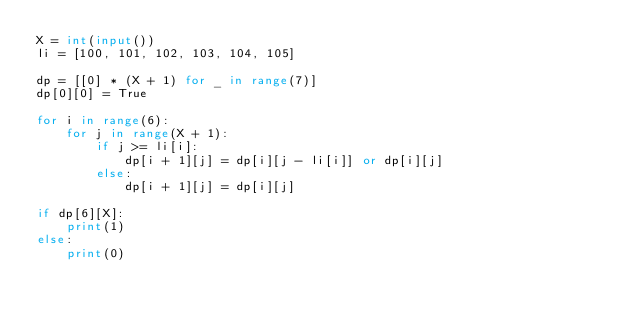<code> <loc_0><loc_0><loc_500><loc_500><_Python_>X = int(input())
li = [100, 101, 102, 103, 104, 105]

dp = [[0] * (X + 1) for _ in range(7)]
dp[0][0] = True

for i in range(6):
    for j in range(X + 1):
        if j >= li[i]:
            dp[i + 1][j] = dp[i][j - li[i]] or dp[i][j]
        else:
            dp[i + 1][j] = dp[i][j]

if dp[6][X]:
    print(1)
else:
    print(0)</code> 